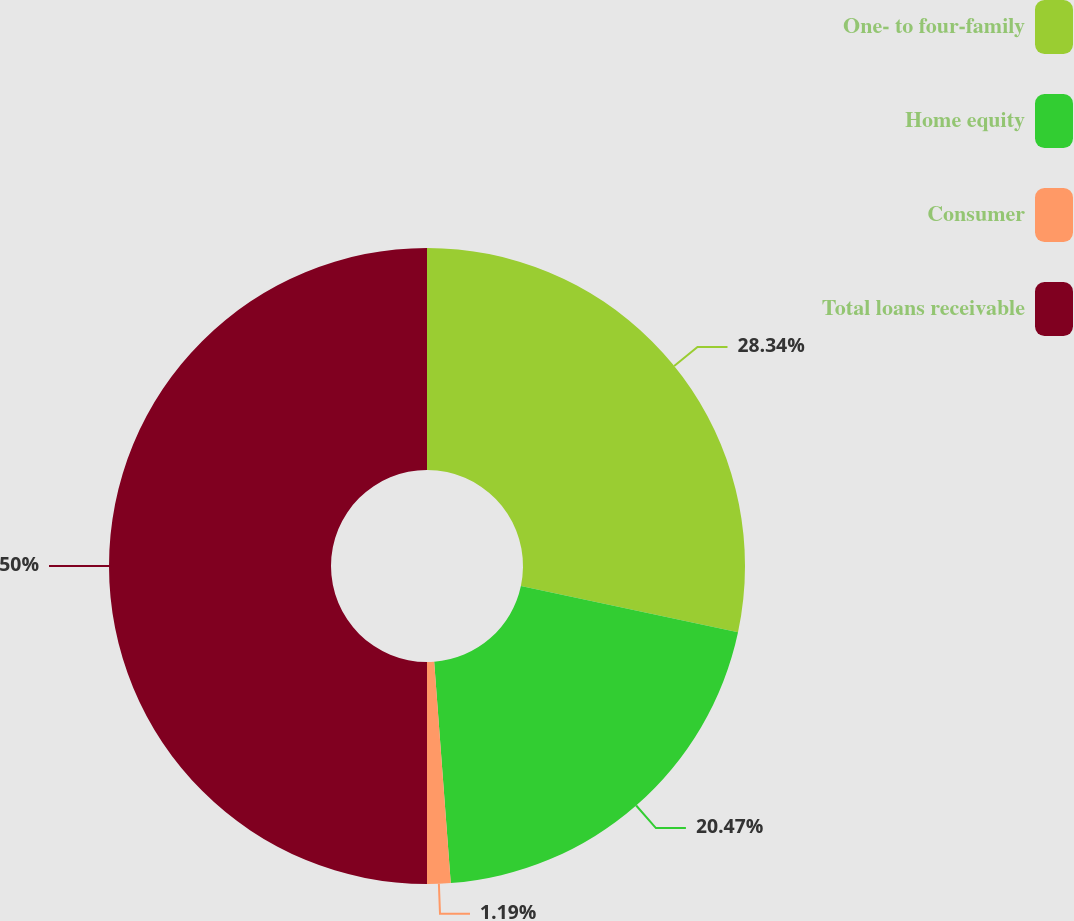Convert chart to OTSL. <chart><loc_0><loc_0><loc_500><loc_500><pie_chart><fcel>One- to four-family<fcel>Home equity<fcel>Consumer<fcel>Total loans receivable<nl><fcel>28.34%<fcel>20.47%<fcel>1.19%<fcel>50.0%<nl></chart> 